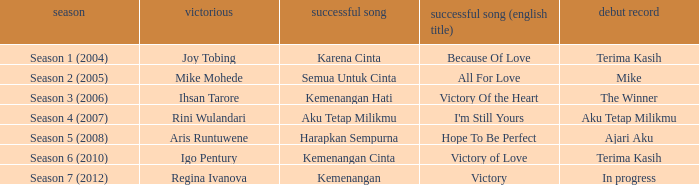Which winning song was sung by aku tetap milikmu? I'm Still Yours. 